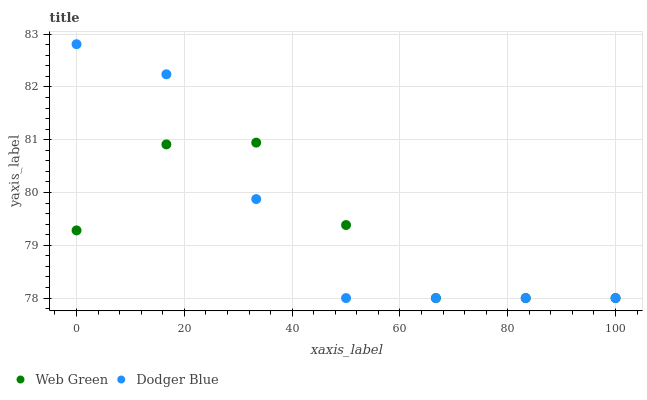Does Web Green have the minimum area under the curve?
Answer yes or no. Yes. Does Dodger Blue have the maximum area under the curve?
Answer yes or no. Yes. Does Web Green have the maximum area under the curve?
Answer yes or no. No. Is Dodger Blue the smoothest?
Answer yes or no. Yes. Is Web Green the roughest?
Answer yes or no. Yes. Is Web Green the smoothest?
Answer yes or no. No. Does Dodger Blue have the lowest value?
Answer yes or no. Yes. Does Dodger Blue have the highest value?
Answer yes or no. Yes. Does Web Green have the highest value?
Answer yes or no. No. Does Web Green intersect Dodger Blue?
Answer yes or no. Yes. Is Web Green less than Dodger Blue?
Answer yes or no. No. Is Web Green greater than Dodger Blue?
Answer yes or no. No. 